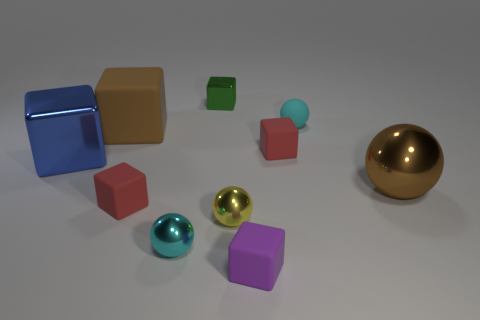How many cyan balls must be subtracted to get 1 cyan balls? 1 Subtract all purple blocks. How many blocks are left? 5 Subtract all purple rubber cubes. How many cubes are left? 5 Subtract all brown cubes. Subtract all red spheres. How many cubes are left? 5 Subtract all balls. How many objects are left? 6 Add 6 tiny purple rubber blocks. How many tiny purple rubber blocks are left? 7 Add 4 purple rubber things. How many purple rubber things exist? 5 Subtract 0 gray blocks. How many objects are left? 10 Subtract all yellow spheres. Subtract all large yellow rubber cylinders. How many objects are left? 9 